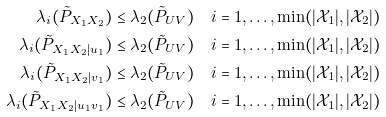<formula> <loc_0><loc_0><loc_500><loc_500>\lambda _ { i } ( \tilde { P } _ { X _ { 1 } X _ { 2 } } ) & \leq \lambda _ { 2 } ( \tilde { P } _ { U V } ) \quad i = 1 , \dots , \min ( | \mathcal { X } _ { 1 } | , | \mathcal { X } _ { 2 } | ) \\ \lambda _ { i } ( \tilde { P } _ { X _ { 1 } X _ { 2 } | u _ { 1 } } ) & \leq \lambda _ { 2 } ( \tilde { P } _ { U V } ) \quad i = 1 , \dots , \min ( | \mathcal { X } _ { 1 } | , | \mathcal { X } _ { 2 } | ) \\ \lambda _ { i } ( \tilde { P } _ { X _ { 1 } X _ { 2 } | v _ { 1 } } ) & \leq \lambda _ { 2 } ( \tilde { P } _ { U V } ) \quad i = 1 , \dots , \min ( | \mathcal { X } _ { 1 } | , | \mathcal { X } _ { 2 } | ) \\ \lambda _ { i } ( \tilde { P } _ { X _ { 1 } X _ { 2 } | u _ { 1 } v _ { 1 } } ) & \leq \lambda _ { 2 } ( \tilde { P } _ { U V } ) \quad i = 1 , \dots , \min ( | \mathcal { X } _ { 1 } | , | \mathcal { X } _ { 2 } | )</formula> 